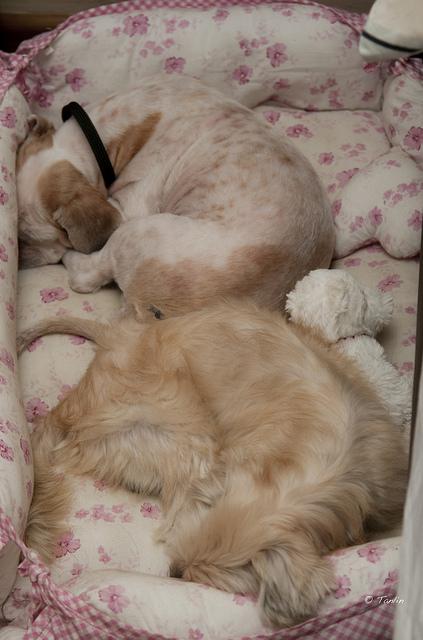What type of animals are they?
Keep it brief. Dogs. Where are the dogs sleeping at?
Be succinct. Bed. What are the animals laying in?
Write a very short answer. Bed. 